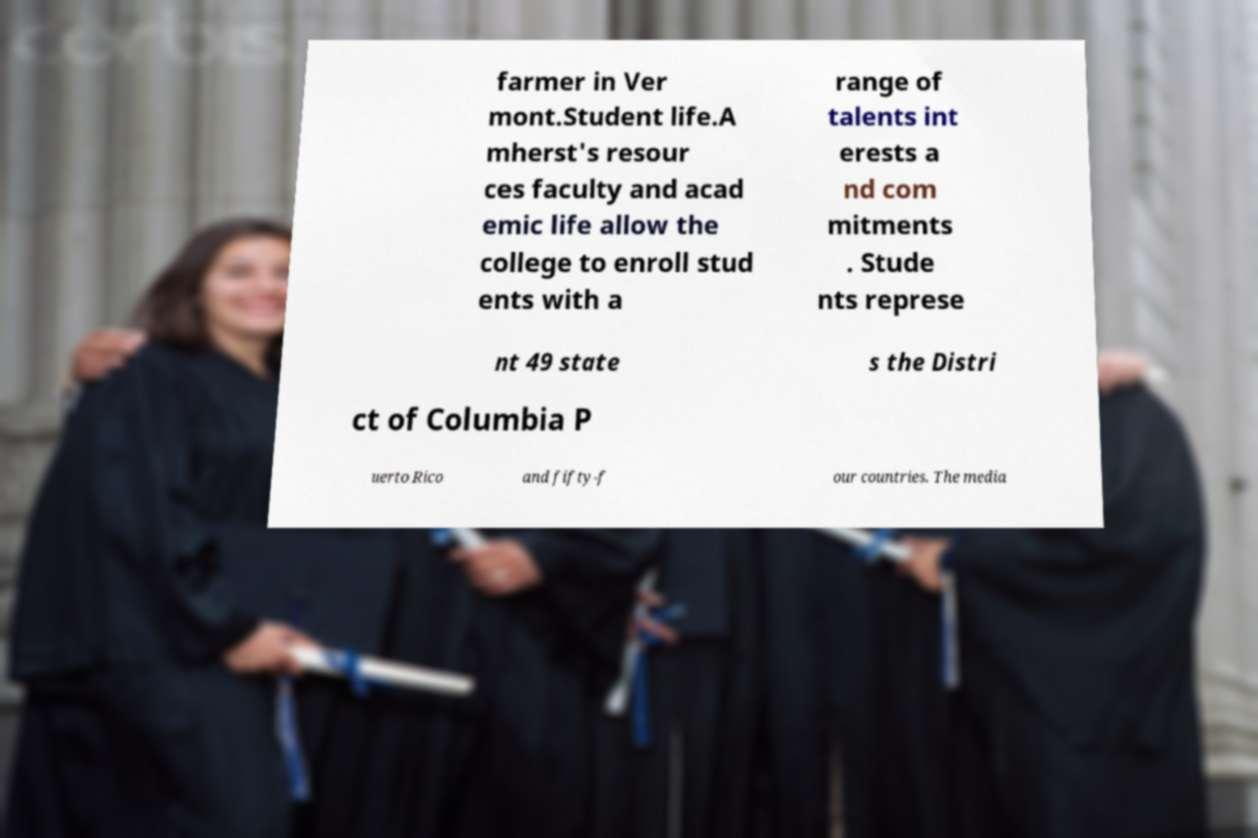Can you accurately transcribe the text from the provided image for me? farmer in Ver mont.Student life.A mherst's resour ces faculty and acad emic life allow the college to enroll stud ents with a range of talents int erests a nd com mitments . Stude nts represe nt 49 state s the Distri ct of Columbia P uerto Rico and fifty-f our countries. The media 